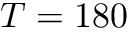Convert formula to latex. <formula><loc_0><loc_0><loc_500><loc_500>T = 1 8 0</formula> 